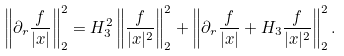<formula> <loc_0><loc_0><loc_500><loc_500>\left \| \partial _ { r } \frac { f } { | x | } \right \| _ { 2 } ^ { 2 } = H _ { 3 } ^ { 2 } \left \| \frac { f } { | x | ^ { 2 } } \right \| _ { 2 } ^ { 2 } + \left \| \partial _ { r } \frac { f } { | x | } + H _ { 3 } \frac { f } { | x | ^ { 2 } } \right \| _ { 2 } ^ { 2 } .</formula> 